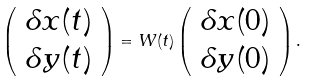<formula> <loc_0><loc_0><loc_500><loc_500>\left ( \begin{array} { c } \delta x ( t ) \\ \delta y ( t ) \end{array} \right ) = W ( t ) \left ( \begin{array} { c } \delta x ( 0 ) \\ \delta y ( 0 ) \end{array} \right ) .</formula> 